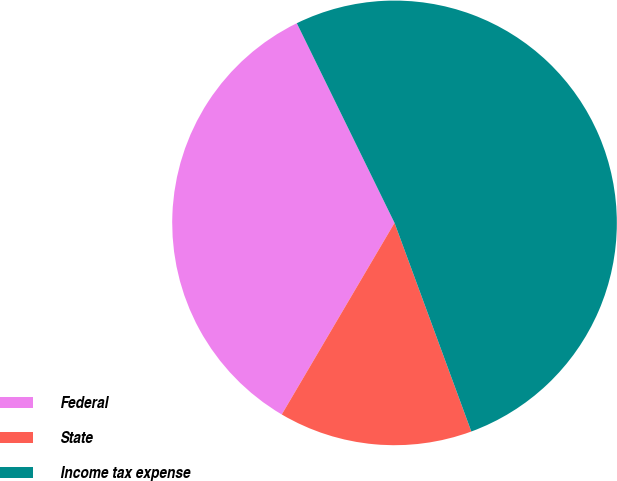<chart> <loc_0><loc_0><loc_500><loc_500><pie_chart><fcel>Federal<fcel>State<fcel>Income tax expense<nl><fcel>34.29%<fcel>14.08%<fcel>51.63%<nl></chart> 